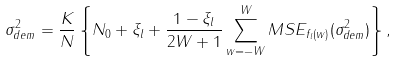Convert formula to latex. <formula><loc_0><loc_0><loc_500><loc_500>\sigma _ { d e m } ^ { 2 } = \frac { K } { N } \left \{ N _ { 0 } + \xi _ { l } + \frac { 1 - \xi _ { l } } { 2 W + 1 } \sum _ { w = - W } ^ { W } M S E _ { f _ { l } ( w ) } ( \sigma _ { d e m } ^ { 2 } ) \right \} ,</formula> 